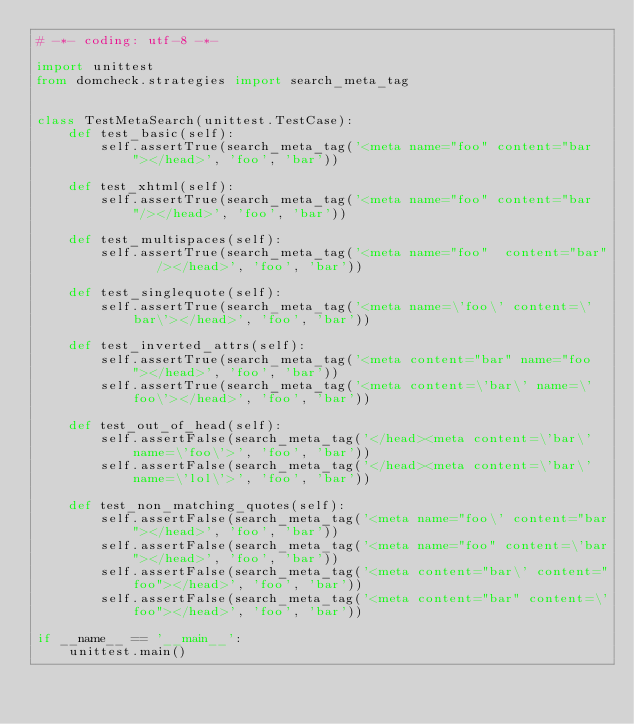<code> <loc_0><loc_0><loc_500><loc_500><_Python_># -*- coding: utf-8 -*-

import unittest
from domcheck.strategies import search_meta_tag


class TestMetaSearch(unittest.TestCase):
    def test_basic(self):
        self.assertTrue(search_meta_tag('<meta name="foo" content="bar"></head>', 'foo', 'bar'))

    def test_xhtml(self):
        self.assertTrue(search_meta_tag('<meta name="foo" content="bar"/></head>', 'foo', 'bar'))

    def test_multispaces(self):
        self.assertTrue(search_meta_tag('<meta name="foo"  content="bar"   /></head>', 'foo', 'bar'))

    def test_singlequote(self):
        self.assertTrue(search_meta_tag('<meta name=\'foo\' content=\'bar\'></head>', 'foo', 'bar'))

    def test_inverted_attrs(self):
        self.assertTrue(search_meta_tag('<meta content="bar" name="foo"></head>', 'foo', 'bar'))
        self.assertTrue(search_meta_tag('<meta content=\'bar\' name=\'foo\'></head>', 'foo', 'bar'))

    def test_out_of_head(self):
        self.assertFalse(search_meta_tag('</head><meta content=\'bar\' name=\'foo\'>', 'foo', 'bar'))
        self.assertFalse(search_meta_tag('</head><meta content=\'bar\' name=\'lol\'>', 'foo', 'bar'))

    def test_non_matching_quotes(self):
        self.assertFalse(search_meta_tag('<meta name="foo\' content="bar"></head>', 'foo', 'bar'))
        self.assertFalse(search_meta_tag('<meta name="foo" content=\'bar"></head>', 'foo', 'bar'))
        self.assertFalse(search_meta_tag('<meta content="bar\' content="foo"></head>', 'foo', 'bar'))
        self.assertFalse(search_meta_tag('<meta content="bar" content=\'foo"></head>', 'foo', 'bar'))

if __name__ == '__main__':
    unittest.main()
</code> 